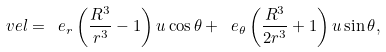Convert formula to latex. <formula><loc_0><loc_0><loc_500><loc_500>\ v e l = \ e _ { r } \left ( \frac { R ^ { 3 } } { r ^ { 3 } } - 1 \right ) u \cos \theta + \ e _ { \theta } \left ( \frac { R ^ { 3 } } { 2 r ^ { 3 } } + 1 \right ) u \sin \theta ,</formula> 